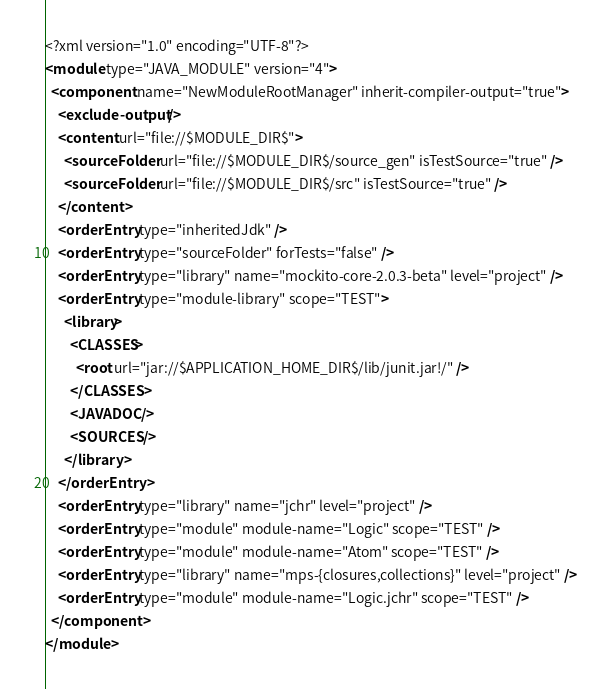Convert code to text. <code><loc_0><loc_0><loc_500><loc_500><_XML_><?xml version="1.0" encoding="UTF-8"?>
<module type="JAVA_MODULE" version="4">
  <component name="NewModuleRootManager" inherit-compiler-output="true">
    <exclude-output />
    <content url="file://$MODULE_DIR$">
      <sourceFolder url="file://$MODULE_DIR$/source_gen" isTestSource="true" />
      <sourceFolder url="file://$MODULE_DIR$/src" isTestSource="true" />
    </content>
    <orderEntry type="inheritedJdk" />
    <orderEntry type="sourceFolder" forTests="false" />
    <orderEntry type="library" name="mockito-core-2.0.3-beta" level="project" />
    <orderEntry type="module-library" scope="TEST">
      <library>
        <CLASSES>
          <root url="jar://$APPLICATION_HOME_DIR$/lib/junit.jar!/" />
        </CLASSES>
        <JAVADOC />
        <SOURCES />
      </library>
    </orderEntry>
    <orderEntry type="library" name="jchr" level="project" />
    <orderEntry type="module" module-name="Logic" scope="TEST" />
    <orderEntry type="module" module-name="Atom" scope="TEST" />
    <orderEntry type="library" name="mps-{closures,collections}" level="project" />
    <orderEntry type="module" module-name="Logic.jchr" scope="TEST" />
  </component>
</module></code> 